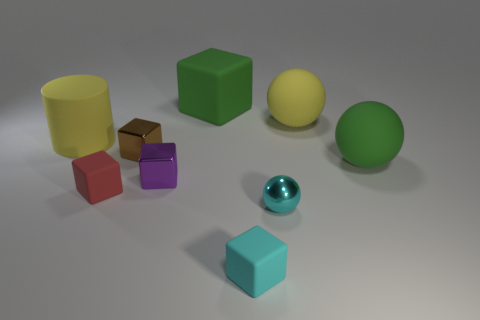Subtract 1 blocks. How many blocks are left? 4 Subtract all tiny purple blocks. How many blocks are left? 4 Subtract all green blocks. How many blocks are left? 4 Subtract all yellow blocks. Subtract all gray cylinders. How many blocks are left? 5 Add 1 metallic blocks. How many objects exist? 10 Subtract all cylinders. How many objects are left? 8 Add 6 cyan metal spheres. How many cyan metal spheres exist? 7 Subtract 1 red blocks. How many objects are left? 8 Subtract all cyan rubber objects. Subtract all purple cubes. How many objects are left? 7 Add 3 green cubes. How many green cubes are left? 4 